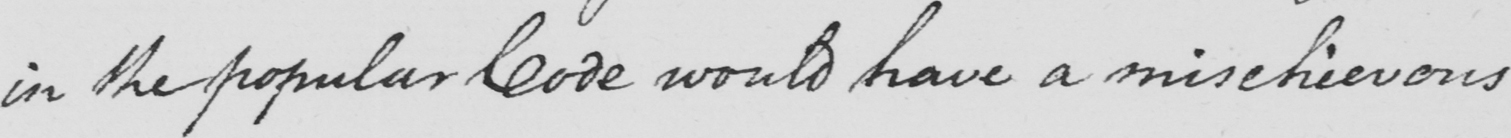Please transcribe the handwritten text in this image. in the popular Code would have a mischievous 